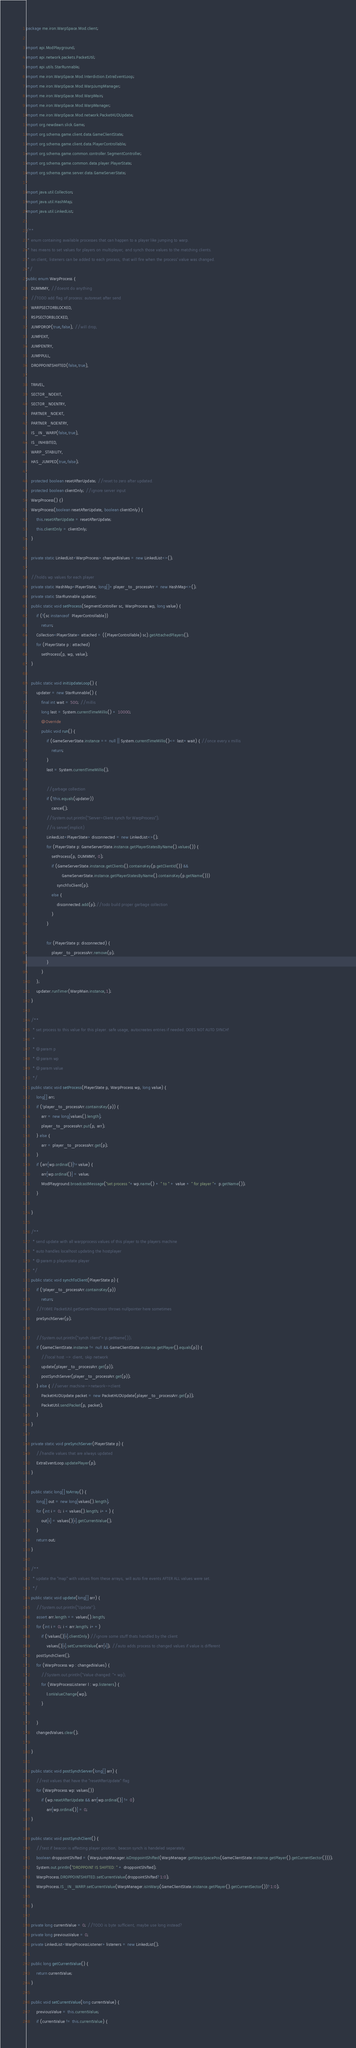<code> <loc_0><loc_0><loc_500><loc_500><_Java_>package me.iron.WarpSpace.Mod.client;

import api.ModPlayground;
import api.network.packets.PacketUtil;
import api.utils.StarRunnable;
import me.iron.WarpSpace.Mod.Interdiction.ExtraEventLoop;
import me.iron.WarpSpace.Mod.WarpJumpManager;
import me.iron.WarpSpace.Mod.WarpMain;
import me.iron.WarpSpace.Mod.WarpManager;
import me.iron.WarpSpace.Mod.network.PacketHUDUpdate;
import org.newdawn.slick.Game;
import org.schema.game.client.data.GameClientState;
import org.schema.game.client.data.PlayerControllable;
import org.schema.game.common.controller.SegmentController;
import org.schema.game.common.data.player.PlayerState;
import org.schema.game.server.data.GameServerState;

import java.util.Collection;
import java.util.HashMap;
import java.util.LinkedList;

/**
 * enum containing available processes that can happen to a player like jumping to warp.
 * has means to set values for players on multiplayer, and synch those values to the matching clients.
 * on client, listeners can be added to each process, that will fire when the process' value was changed.
 */
public enum WarpProcess {
    DUMMMY, //doesnt do anything
    //TODO add flag of process: autoreset after send
    WARPSECTORBLOCKED,
    RSPSECTORBLOCKED,
    JUMPDROP(true,false), //will drop,
    JUMPEXIT,
    JUMPENTRY,
    JUMPPULL,
    DROPPOINTSHIFTED(false,true),

    TRAVEL,
    SECTOR_NOEXIT,
    SECTOR_NOENTRY,
    PARTNER_NOEXIT,
    PARTNER_NOENTRY,
    IS_IN_WARP(false,true),
    IS_INHIBITED,
    WARP_STABILITY,
    HAS_JUMPED(true,false);

    protected boolean resetAfterUpdate; //reset to zero after updated.
    protected boolean clientOnly; //ignore server input
    WarpProcess() {}
    WarpProcess(boolean resetAfterUpdate, boolean clientOnly) {
        this.resetAfterUpdate = resetAfterUpdate;
        this.clientOnly = clientOnly;
    }

    private static LinkedList<WarpProcess> changedValues = new LinkedList<>();

    //holds wp values for each player
    private static HashMap<PlayerState, long[]> player_to_processArr = new HashMap<>();
    private static StarRunnable updater;
    public static void setProcess(SegmentController sc, WarpProcess wp, long value) {
        if (!(sc instanceof  PlayerControllable))
            return;
        Collection<PlayerState> attached = ((PlayerControllable) sc).getAttachedPlayers();
        for (PlayerState p : attached)
            setProcess(p, wp, value);
    }

    public static void initUpdateLoop() {
        updater = new StarRunnable() {
            final int wait = 500; //millis
            long last = System.currentTimeMillis() + 10000;
            @Override
            public void run() {
                if (GameServerState.instance == null || System.currentTimeMillis()<= last+wait) { //once every x millis
                    return;
                }
                last = System.currentTimeMillis();

                //garbage collection
                if (!this.equals(updater))
                    cancel();
                //System.out.println("Server-Client synch for WarpProcess");
                //is server(implicit)
                LinkedList<PlayerState> disconnected = new LinkedList<>();
                for (PlayerState p: GameServerState.instance.getPlayerStatesByName().values()) {
                    setProcess(p, DUMMMY, 0);
                    if (GameServerState.instance.getClients().containsKey(p.getClientId()) &&
                            GameServerState.instance.getPlayerStatesByName().containsKey(p.getName()))
                        synchToClient(p);
                    else {
                        disconnected.add(p);//todo build proper garbage collection
                    }
                }

                for (PlayerState p: disconnected) {
                    player_to_processArr.remove(p);
                }
            }
        };
        updater.runTimer(WarpMain.instance,1);
    }

    /**
     * set process to this value for this player. safe usage, autocreates entries if needed. DOES NOT AUTO SYNCH!
     *
     * @param p
     * @param wp
     * @param value
     */
    public static void setProcess(PlayerState p, WarpProcess wp, long value) {
        long[] arr;
        if (!player_to_processArr.containsKey(p)) {
            arr = new long[values().length];
            player_to_processArr.put(p, arr);
        } else {
            arr = player_to_processArr.get(p);
        }
        if (arr[wp.ordinal()]!=value) {
            arr[wp.ordinal()] = value;
            ModPlayground.broadcastMessage("set process "+wp.name() + " to " + value + " for player "+ p.getName());
        }

    }

    /**
     * send update with all warpprocess values of this player to the players machine
     * auto handles localhost updating the hostplayer
     * @param p playerstate player
     */
    public static void synchToClient(PlayerState p) {
        if (!player_to_processArr.containsKey(p))
            return;
        //FIXME PacketUtil.getServerProcessor throws nullpointer here sometimes
        preSynchServer(p);

        //System.out.println("synch client"+p.getName());
        if (GameClientState.instance != null && GameClientState.instance.getPlayer().equals(p)) {
            //local host -> client, skip network
            update(player_to_processArr.get(p));
            postSynchServer(player_to_processArr.get(p));
        } else { //server machine->network->client
            PacketHUDUpdate packet = new PacketHUDUpdate(player_to_processArr.get(p));
            PacketUtil.sendPacket(p, packet);
        }
    }

    private static void preSynchServer(PlayerState p) {
        //handle values that are always updated
        ExtraEventLoop.updatePlayer(p);
    }

    public static long[] toArray() {
        long[] out = new long[values().length];
        for (int i = 0; i < values().length; i++) {
            out[i] = values()[i].getCurrentValue();
        }
        return out;
    }

    /**
     * update the "map" with values from these arrays, will auto fire events AFTER ALL values were set.
     */
    public static void update(long[] arr) {
        //System.out.println("Update");
        assert arr.length == values().length;
        for (int i = 0; i < arr.length; i++)
            if (!values()[i].clientOnly) //ignore some stuff thats handled by the client
                values()[i].setCurrentValue(arr[i]); //auto adds process to changed values if value is different
        postSynchClient();
        for (WarpProcess wp : changedValues) {
            //System.out.println("Value changed: "+wp);
            for (WarpProcessListener l : wp.listeners) {
                l.onValueChange(wp);
            }

        }
        changedValues.clear();

    }

    public static void postSynchServer(long[] arr) {
        //rest values that have the "resetAfterUpdate" flag
        for (WarpProcess wp: values())
            if (wp.resetAfterUpdate && arr[wp.ordinal()] != 0)
                arr[wp.ordinal()] = 0;
    }

    public static void postSynchClient() {
        //test if beacon is affecting player position, beacon synch is handeled separately.
        boolean droppointShifted = (WarpJumpManager.isDroppointShifted(WarpManager.getWarpSpacePos(GameClientState.instance.getPlayer().getCurrentSector())));
        System.out.println("DROPPOINT IS SHIFTED: " + droppointShifted);
        WarpProcess.DROPPOINTSHIFTED.setCurrentValue(droppointShifted?1:0);
        WarpProcess.IS_IN_WARP.setCurrentValue(WarpManager.isInWarp(GameClientState.instance.getPlayer().getCurrentSector())?1:0);

    }

    private long currentValue = 0; //TODO is byte sufficient, maybe use long instead?
    private long previousValue = 0;
    private LinkedList<WarpProcessListener> listeners = new LinkedList();

    public long getCurrentValue() {
        return currentValue;
    }

    public void setCurrentValue(long currentValue) {
        previousValue = this.currentValue;
        if (currentValue != this.currentValue) {</code> 